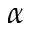Convert formula to latex. <formula><loc_0><loc_0><loc_500><loc_500>\alpha</formula> 